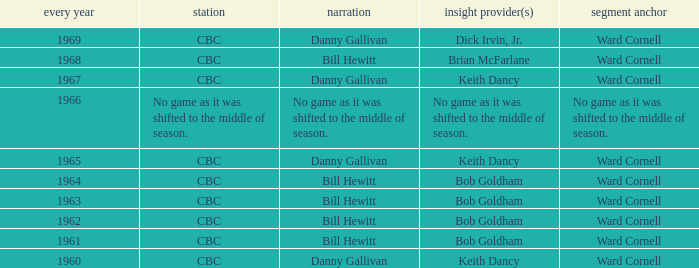Can you give me this table as a dict? {'header': ['every year', 'station', 'narration', 'insight provider(s)', 'segment anchor'], 'rows': [['1969', 'CBC', 'Danny Gallivan', 'Dick Irvin, Jr.', 'Ward Cornell'], ['1968', 'CBC', 'Bill Hewitt', 'Brian McFarlane', 'Ward Cornell'], ['1967', 'CBC', 'Danny Gallivan', 'Keith Dancy', 'Ward Cornell'], ['1966', 'No game as it was shifted to the middle of season.', 'No game as it was shifted to the middle of season.', 'No game as it was shifted to the middle of season.', 'No game as it was shifted to the middle of season.'], ['1965', 'CBC', 'Danny Gallivan', 'Keith Dancy', 'Ward Cornell'], ['1964', 'CBC', 'Bill Hewitt', 'Bob Goldham', 'Ward Cornell'], ['1963', 'CBC', 'Bill Hewitt', 'Bob Goldham', 'Ward Cornell'], ['1962', 'CBC', 'Bill Hewitt', 'Bob Goldham', 'Ward Cornell'], ['1961', 'CBC', 'Bill Hewitt', 'Bob Goldham', 'Ward Cornell'], ['1960', 'CBC', 'Danny Gallivan', 'Keith Dancy', 'Ward Cornell']]} Who did the play-by-play on the CBC network before 1961? Danny Gallivan. 